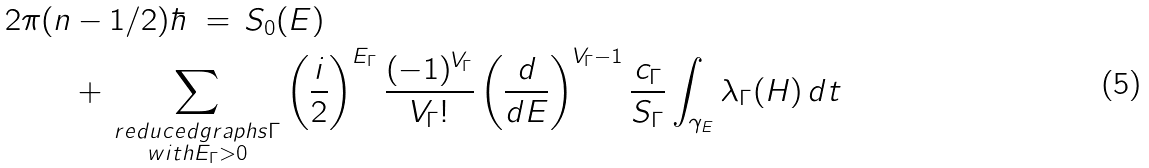Convert formula to latex. <formula><loc_0><loc_0><loc_500><loc_500>2 \pi ( n & - 1 / 2 ) \hbar { \, } \, = \, S _ { 0 } ( E ) \, \\ & + \, \sum _ { \substack { r e d u c e d g r a p h s \Gamma \\ w i t h E _ { \Gamma } > 0 } } \left ( \frac { i } { 2 } \right ) ^ { E _ { \Gamma } } \frac { ( - 1 ) ^ { V _ { \Gamma } } } { { V _ { \Gamma } } ! } \left ( \frac { d } { d E } \right ) ^ { V _ { \Gamma } - 1 } \frac { c _ { \Gamma } } { S _ { \Gamma } } \int _ { \gamma _ { E } } \lambda _ { \Gamma } ( H ) \, d t</formula> 